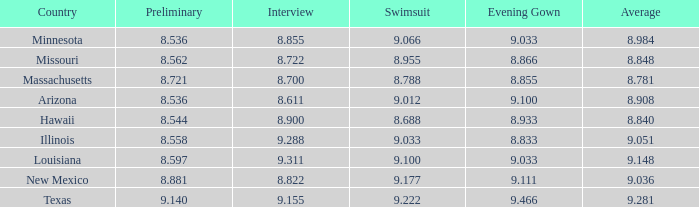What was the swimsuit score for Illinois? 9.033. 